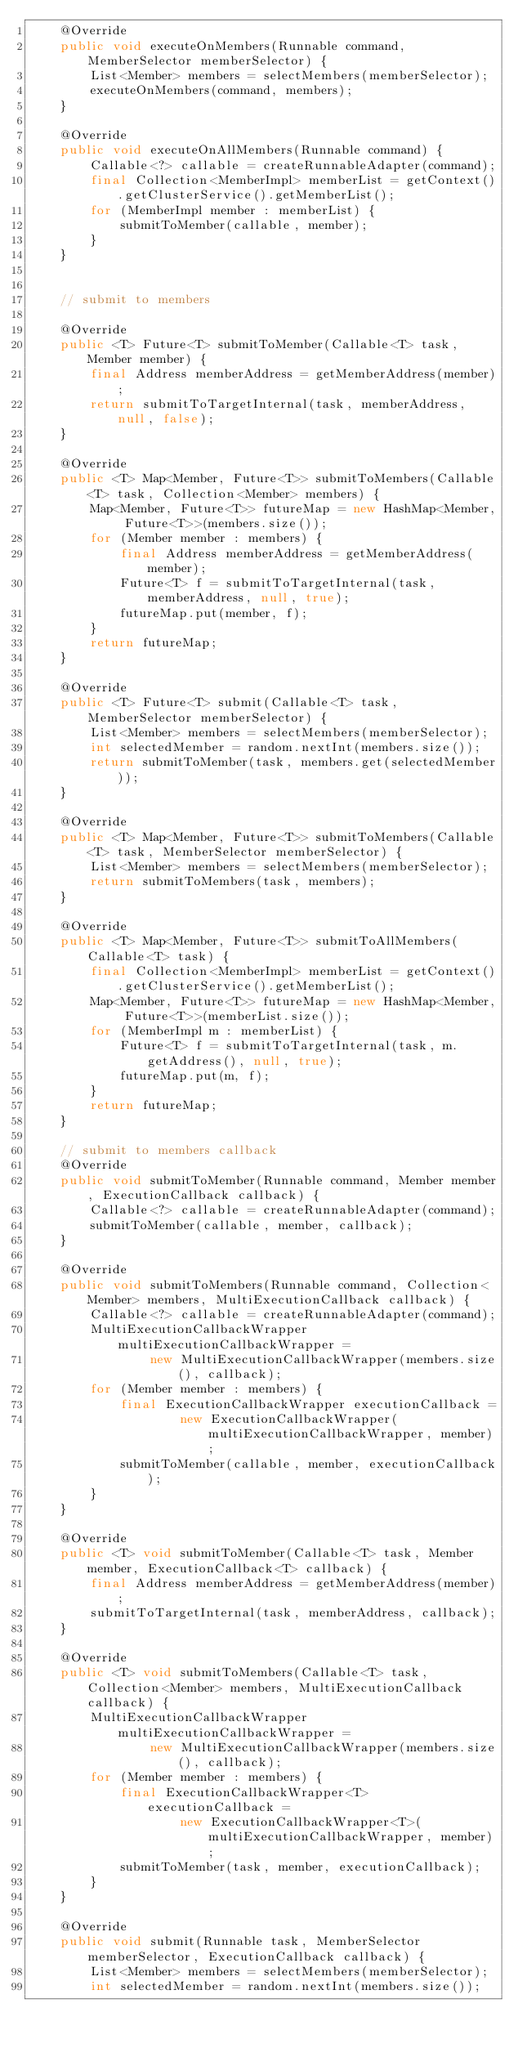Convert code to text. <code><loc_0><loc_0><loc_500><loc_500><_Java_>    @Override
    public void executeOnMembers(Runnable command, MemberSelector memberSelector) {
        List<Member> members = selectMembers(memberSelector);
        executeOnMembers(command, members);
    }

    @Override
    public void executeOnAllMembers(Runnable command) {
        Callable<?> callable = createRunnableAdapter(command);
        final Collection<MemberImpl> memberList = getContext().getClusterService().getMemberList();
        for (MemberImpl member : memberList) {
            submitToMember(callable, member);
        }
    }


    // submit to members

    @Override
    public <T> Future<T> submitToMember(Callable<T> task, Member member) {
        final Address memberAddress = getMemberAddress(member);
        return submitToTargetInternal(task, memberAddress, null, false);
    }

    @Override
    public <T> Map<Member, Future<T>> submitToMembers(Callable<T> task, Collection<Member> members) {
        Map<Member, Future<T>> futureMap = new HashMap<Member, Future<T>>(members.size());
        for (Member member : members) {
            final Address memberAddress = getMemberAddress(member);
            Future<T> f = submitToTargetInternal(task, memberAddress, null, true);
            futureMap.put(member, f);
        }
        return futureMap;
    }

    @Override
    public <T> Future<T> submit(Callable<T> task, MemberSelector memberSelector) {
        List<Member> members = selectMembers(memberSelector);
        int selectedMember = random.nextInt(members.size());
        return submitToMember(task, members.get(selectedMember));
    }

    @Override
    public <T> Map<Member, Future<T>> submitToMembers(Callable<T> task, MemberSelector memberSelector) {
        List<Member> members = selectMembers(memberSelector);
        return submitToMembers(task, members);
    }

    @Override
    public <T> Map<Member, Future<T>> submitToAllMembers(Callable<T> task) {
        final Collection<MemberImpl> memberList = getContext().getClusterService().getMemberList();
        Map<Member, Future<T>> futureMap = new HashMap<Member, Future<T>>(memberList.size());
        for (MemberImpl m : memberList) {
            Future<T> f = submitToTargetInternal(task, m.getAddress(), null, true);
            futureMap.put(m, f);
        }
        return futureMap;
    }

    // submit to members callback
    @Override
    public void submitToMember(Runnable command, Member member, ExecutionCallback callback) {
        Callable<?> callable = createRunnableAdapter(command);
        submitToMember(callable, member, callback);
    }

    @Override
    public void submitToMembers(Runnable command, Collection<Member> members, MultiExecutionCallback callback) {
        Callable<?> callable = createRunnableAdapter(command);
        MultiExecutionCallbackWrapper multiExecutionCallbackWrapper =
                new MultiExecutionCallbackWrapper(members.size(), callback);
        for (Member member : members) {
            final ExecutionCallbackWrapper executionCallback =
                    new ExecutionCallbackWrapper(multiExecutionCallbackWrapper, member);
            submitToMember(callable, member, executionCallback);
        }
    }

    @Override
    public <T> void submitToMember(Callable<T> task, Member member, ExecutionCallback<T> callback) {
        final Address memberAddress = getMemberAddress(member);
        submitToTargetInternal(task, memberAddress, callback);
    }

    @Override
    public <T> void submitToMembers(Callable<T> task, Collection<Member> members, MultiExecutionCallback callback) {
        MultiExecutionCallbackWrapper multiExecutionCallbackWrapper =
                new MultiExecutionCallbackWrapper(members.size(), callback);
        for (Member member : members) {
            final ExecutionCallbackWrapper<T> executionCallback =
                    new ExecutionCallbackWrapper<T>(multiExecutionCallbackWrapper, member);
            submitToMember(task, member, executionCallback);
        }
    }

    @Override
    public void submit(Runnable task, MemberSelector memberSelector, ExecutionCallback callback) {
        List<Member> members = selectMembers(memberSelector);
        int selectedMember = random.nextInt(members.size());</code> 